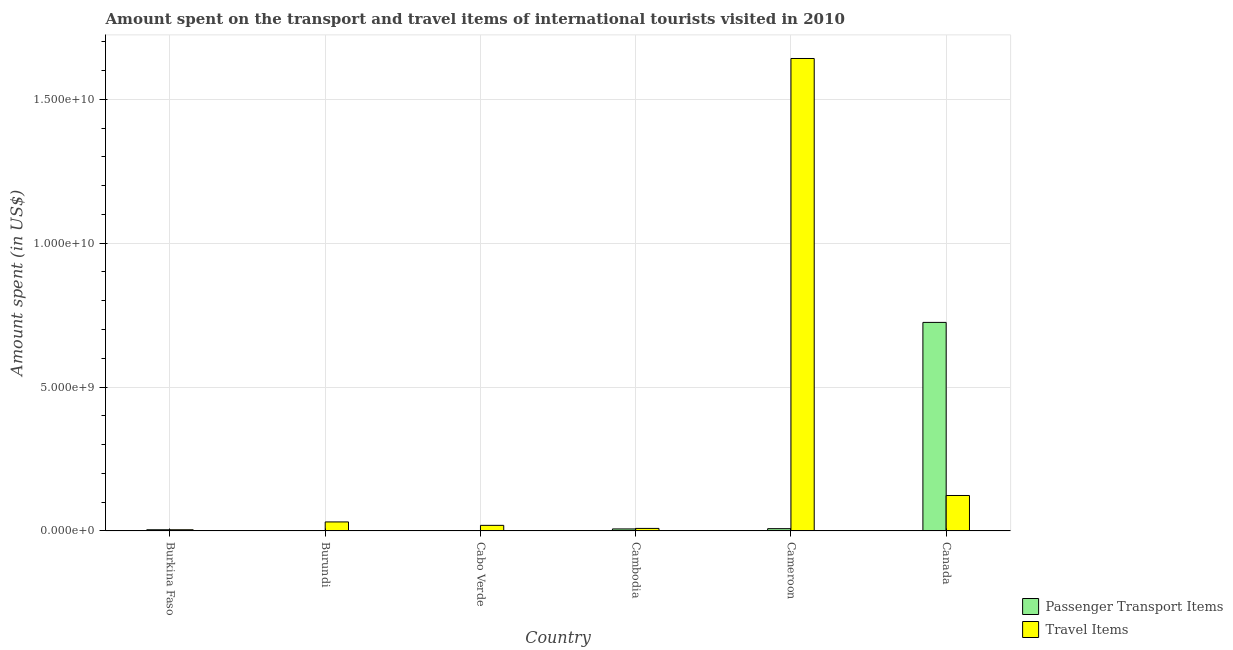How many groups of bars are there?
Your answer should be compact. 6. Are the number of bars on each tick of the X-axis equal?
Provide a short and direct response. Yes. How many bars are there on the 3rd tick from the left?
Provide a succinct answer. 2. How many bars are there on the 1st tick from the right?
Make the answer very short. 2. What is the label of the 3rd group of bars from the left?
Your answer should be compact. Cabo Verde. In how many cases, is the number of bars for a given country not equal to the number of legend labels?
Your response must be concise. 0. What is the amount spent in travel items in Burundi?
Offer a terse response. 3.13e+08. Across all countries, what is the maximum amount spent in travel items?
Your answer should be very brief. 1.64e+1. Across all countries, what is the minimum amount spent in travel items?
Give a very brief answer. 4.10e+07. In which country was the amount spent on passenger transport items maximum?
Offer a terse response. Canada. In which country was the amount spent in travel items minimum?
Provide a short and direct response. Burkina Faso. What is the total amount spent in travel items in the graph?
Offer a terse response. 1.83e+1. What is the difference between the amount spent on passenger transport items in Cambodia and that in Cameroon?
Make the answer very short. -9.00e+06. What is the difference between the amount spent on passenger transport items in Burundi and the amount spent in travel items in Cameroon?
Your answer should be compact. -1.64e+1. What is the average amount spent in travel items per country?
Keep it short and to the point. 3.05e+09. What is the difference between the amount spent in travel items and amount spent on passenger transport items in Burkina Faso?
Ensure brevity in your answer.  0. What is the ratio of the amount spent on passenger transport items in Burundi to that in Cabo Verde?
Provide a short and direct response. 1.67. Is the amount spent on passenger transport items in Burundi less than that in Cameroon?
Your response must be concise. Yes. Is the difference between the amount spent in travel items in Cameroon and Canada greater than the difference between the amount spent on passenger transport items in Cameroon and Canada?
Provide a succinct answer. Yes. What is the difference between the highest and the second highest amount spent in travel items?
Keep it short and to the point. 1.52e+1. What is the difference between the highest and the lowest amount spent on passenger transport items?
Make the answer very short. 7.24e+09. In how many countries, is the amount spent in travel items greater than the average amount spent in travel items taken over all countries?
Ensure brevity in your answer.  1. What does the 1st bar from the left in Canada represents?
Provide a short and direct response. Passenger Transport Items. What does the 1st bar from the right in Burundi represents?
Give a very brief answer. Travel Items. Are all the bars in the graph horizontal?
Your answer should be very brief. No. How many countries are there in the graph?
Offer a very short reply. 6. What is the difference between two consecutive major ticks on the Y-axis?
Keep it short and to the point. 5.00e+09. Does the graph contain any zero values?
Your answer should be compact. No. Does the graph contain grids?
Your answer should be compact. Yes. How many legend labels are there?
Give a very brief answer. 2. What is the title of the graph?
Keep it short and to the point. Amount spent on the transport and travel items of international tourists visited in 2010. Does "Technicians" appear as one of the legend labels in the graph?
Your answer should be very brief. No. What is the label or title of the Y-axis?
Keep it short and to the point. Amount spent (in US$). What is the Amount spent (in US$) in Passenger Transport Items in Burkina Faso?
Offer a terse response. 4.10e+07. What is the Amount spent (in US$) of Travel Items in Burkina Faso?
Ensure brevity in your answer.  4.10e+07. What is the Amount spent (in US$) in Passenger Transport Items in Burundi?
Ensure brevity in your answer.  1.50e+07. What is the Amount spent (in US$) in Travel Items in Burundi?
Offer a terse response. 3.13e+08. What is the Amount spent (in US$) of Passenger Transport Items in Cabo Verde?
Provide a short and direct response. 9.00e+06. What is the Amount spent (in US$) of Travel Items in Cabo Verde?
Ensure brevity in your answer.  1.94e+08. What is the Amount spent (in US$) in Passenger Transport Items in Cambodia?
Give a very brief answer. 7.00e+07. What is the Amount spent (in US$) in Travel Items in Cambodia?
Ensure brevity in your answer.  8.80e+07. What is the Amount spent (in US$) in Passenger Transport Items in Cameroon?
Ensure brevity in your answer.  7.90e+07. What is the Amount spent (in US$) in Travel Items in Cameroon?
Give a very brief answer. 1.64e+1. What is the Amount spent (in US$) in Passenger Transport Items in Canada?
Your answer should be very brief. 7.25e+09. What is the Amount spent (in US$) of Travel Items in Canada?
Ensure brevity in your answer.  1.23e+09. Across all countries, what is the maximum Amount spent (in US$) of Passenger Transport Items?
Offer a very short reply. 7.25e+09. Across all countries, what is the maximum Amount spent (in US$) in Travel Items?
Offer a very short reply. 1.64e+1. Across all countries, what is the minimum Amount spent (in US$) in Passenger Transport Items?
Your answer should be compact. 9.00e+06. Across all countries, what is the minimum Amount spent (in US$) of Travel Items?
Keep it short and to the point. 4.10e+07. What is the total Amount spent (in US$) of Passenger Transport Items in the graph?
Offer a very short reply. 7.46e+09. What is the total Amount spent (in US$) of Travel Items in the graph?
Ensure brevity in your answer.  1.83e+1. What is the difference between the Amount spent (in US$) in Passenger Transport Items in Burkina Faso and that in Burundi?
Your answer should be compact. 2.60e+07. What is the difference between the Amount spent (in US$) in Travel Items in Burkina Faso and that in Burundi?
Keep it short and to the point. -2.72e+08. What is the difference between the Amount spent (in US$) in Passenger Transport Items in Burkina Faso and that in Cabo Verde?
Offer a terse response. 3.20e+07. What is the difference between the Amount spent (in US$) of Travel Items in Burkina Faso and that in Cabo Verde?
Your answer should be very brief. -1.53e+08. What is the difference between the Amount spent (in US$) in Passenger Transport Items in Burkina Faso and that in Cambodia?
Keep it short and to the point. -2.90e+07. What is the difference between the Amount spent (in US$) of Travel Items in Burkina Faso and that in Cambodia?
Offer a terse response. -4.70e+07. What is the difference between the Amount spent (in US$) in Passenger Transport Items in Burkina Faso and that in Cameroon?
Your answer should be compact. -3.80e+07. What is the difference between the Amount spent (in US$) in Travel Items in Burkina Faso and that in Cameroon?
Give a very brief answer. -1.64e+1. What is the difference between the Amount spent (in US$) of Passenger Transport Items in Burkina Faso and that in Canada?
Your answer should be compact. -7.21e+09. What is the difference between the Amount spent (in US$) of Travel Items in Burkina Faso and that in Canada?
Provide a succinct answer. -1.19e+09. What is the difference between the Amount spent (in US$) in Passenger Transport Items in Burundi and that in Cabo Verde?
Provide a short and direct response. 6.00e+06. What is the difference between the Amount spent (in US$) in Travel Items in Burundi and that in Cabo Verde?
Offer a terse response. 1.19e+08. What is the difference between the Amount spent (in US$) of Passenger Transport Items in Burundi and that in Cambodia?
Provide a succinct answer. -5.50e+07. What is the difference between the Amount spent (in US$) of Travel Items in Burundi and that in Cambodia?
Make the answer very short. 2.25e+08. What is the difference between the Amount spent (in US$) of Passenger Transport Items in Burundi and that in Cameroon?
Provide a succinct answer. -6.40e+07. What is the difference between the Amount spent (in US$) in Travel Items in Burundi and that in Cameroon?
Your answer should be very brief. -1.61e+1. What is the difference between the Amount spent (in US$) in Passenger Transport Items in Burundi and that in Canada?
Your answer should be very brief. -7.23e+09. What is the difference between the Amount spent (in US$) of Travel Items in Burundi and that in Canada?
Offer a very short reply. -9.19e+08. What is the difference between the Amount spent (in US$) of Passenger Transport Items in Cabo Verde and that in Cambodia?
Your answer should be compact. -6.10e+07. What is the difference between the Amount spent (in US$) of Travel Items in Cabo Verde and that in Cambodia?
Your answer should be very brief. 1.06e+08. What is the difference between the Amount spent (in US$) in Passenger Transport Items in Cabo Verde and that in Cameroon?
Make the answer very short. -7.00e+07. What is the difference between the Amount spent (in US$) of Travel Items in Cabo Verde and that in Cameroon?
Provide a succinct answer. -1.62e+1. What is the difference between the Amount spent (in US$) in Passenger Transport Items in Cabo Verde and that in Canada?
Your answer should be compact. -7.24e+09. What is the difference between the Amount spent (in US$) in Travel Items in Cabo Verde and that in Canada?
Offer a terse response. -1.04e+09. What is the difference between the Amount spent (in US$) of Passenger Transport Items in Cambodia and that in Cameroon?
Keep it short and to the point. -9.00e+06. What is the difference between the Amount spent (in US$) in Travel Items in Cambodia and that in Cameroon?
Your answer should be compact. -1.63e+1. What is the difference between the Amount spent (in US$) of Passenger Transport Items in Cambodia and that in Canada?
Your answer should be very brief. -7.18e+09. What is the difference between the Amount spent (in US$) in Travel Items in Cambodia and that in Canada?
Keep it short and to the point. -1.14e+09. What is the difference between the Amount spent (in US$) in Passenger Transport Items in Cameroon and that in Canada?
Offer a very short reply. -7.17e+09. What is the difference between the Amount spent (in US$) in Travel Items in Cameroon and that in Canada?
Give a very brief answer. 1.52e+1. What is the difference between the Amount spent (in US$) in Passenger Transport Items in Burkina Faso and the Amount spent (in US$) in Travel Items in Burundi?
Give a very brief answer. -2.72e+08. What is the difference between the Amount spent (in US$) in Passenger Transport Items in Burkina Faso and the Amount spent (in US$) in Travel Items in Cabo Verde?
Your response must be concise. -1.53e+08. What is the difference between the Amount spent (in US$) of Passenger Transport Items in Burkina Faso and the Amount spent (in US$) of Travel Items in Cambodia?
Ensure brevity in your answer.  -4.70e+07. What is the difference between the Amount spent (in US$) in Passenger Transport Items in Burkina Faso and the Amount spent (in US$) in Travel Items in Cameroon?
Offer a very short reply. -1.64e+1. What is the difference between the Amount spent (in US$) of Passenger Transport Items in Burkina Faso and the Amount spent (in US$) of Travel Items in Canada?
Offer a terse response. -1.19e+09. What is the difference between the Amount spent (in US$) in Passenger Transport Items in Burundi and the Amount spent (in US$) in Travel Items in Cabo Verde?
Give a very brief answer. -1.79e+08. What is the difference between the Amount spent (in US$) of Passenger Transport Items in Burundi and the Amount spent (in US$) of Travel Items in Cambodia?
Give a very brief answer. -7.30e+07. What is the difference between the Amount spent (in US$) of Passenger Transport Items in Burundi and the Amount spent (in US$) of Travel Items in Cameroon?
Ensure brevity in your answer.  -1.64e+1. What is the difference between the Amount spent (in US$) of Passenger Transport Items in Burundi and the Amount spent (in US$) of Travel Items in Canada?
Your answer should be very brief. -1.22e+09. What is the difference between the Amount spent (in US$) in Passenger Transport Items in Cabo Verde and the Amount spent (in US$) in Travel Items in Cambodia?
Ensure brevity in your answer.  -7.90e+07. What is the difference between the Amount spent (in US$) of Passenger Transport Items in Cabo Verde and the Amount spent (in US$) of Travel Items in Cameroon?
Your answer should be very brief. -1.64e+1. What is the difference between the Amount spent (in US$) of Passenger Transport Items in Cabo Verde and the Amount spent (in US$) of Travel Items in Canada?
Provide a succinct answer. -1.22e+09. What is the difference between the Amount spent (in US$) in Passenger Transport Items in Cambodia and the Amount spent (in US$) in Travel Items in Cameroon?
Provide a succinct answer. -1.64e+1. What is the difference between the Amount spent (in US$) in Passenger Transport Items in Cambodia and the Amount spent (in US$) in Travel Items in Canada?
Your answer should be compact. -1.16e+09. What is the difference between the Amount spent (in US$) in Passenger Transport Items in Cameroon and the Amount spent (in US$) in Travel Items in Canada?
Provide a short and direct response. -1.15e+09. What is the average Amount spent (in US$) of Passenger Transport Items per country?
Keep it short and to the point. 1.24e+09. What is the average Amount spent (in US$) in Travel Items per country?
Your answer should be compact. 3.05e+09. What is the difference between the Amount spent (in US$) of Passenger Transport Items and Amount spent (in US$) of Travel Items in Burkina Faso?
Keep it short and to the point. 0. What is the difference between the Amount spent (in US$) in Passenger Transport Items and Amount spent (in US$) in Travel Items in Burundi?
Provide a succinct answer. -2.98e+08. What is the difference between the Amount spent (in US$) of Passenger Transport Items and Amount spent (in US$) of Travel Items in Cabo Verde?
Your answer should be compact. -1.85e+08. What is the difference between the Amount spent (in US$) of Passenger Transport Items and Amount spent (in US$) of Travel Items in Cambodia?
Your answer should be compact. -1.80e+07. What is the difference between the Amount spent (in US$) in Passenger Transport Items and Amount spent (in US$) in Travel Items in Cameroon?
Keep it short and to the point. -1.63e+1. What is the difference between the Amount spent (in US$) in Passenger Transport Items and Amount spent (in US$) in Travel Items in Canada?
Ensure brevity in your answer.  6.02e+09. What is the ratio of the Amount spent (in US$) of Passenger Transport Items in Burkina Faso to that in Burundi?
Make the answer very short. 2.73. What is the ratio of the Amount spent (in US$) of Travel Items in Burkina Faso to that in Burundi?
Keep it short and to the point. 0.13. What is the ratio of the Amount spent (in US$) in Passenger Transport Items in Burkina Faso to that in Cabo Verde?
Keep it short and to the point. 4.56. What is the ratio of the Amount spent (in US$) in Travel Items in Burkina Faso to that in Cabo Verde?
Your answer should be very brief. 0.21. What is the ratio of the Amount spent (in US$) in Passenger Transport Items in Burkina Faso to that in Cambodia?
Offer a very short reply. 0.59. What is the ratio of the Amount spent (in US$) of Travel Items in Burkina Faso to that in Cambodia?
Provide a succinct answer. 0.47. What is the ratio of the Amount spent (in US$) in Passenger Transport Items in Burkina Faso to that in Cameroon?
Make the answer very short. 0.52. What is the ratio of the Amount spent (in US$) of Travel Items in Burkina Faso to that in Cameroon?
Provide a succinct answer. 0. What is the ratio of the Amount spent (in US$) of Passenger Transport Items in Burkina Faso to that in Canada?
Your response must be concise. 0.01. What is the ratio of the Amount spent (in US$) of Passenger Transport Items in Burundi to that in Cabo Verde?
Give a very brief answer. 1.67. What is the ratio of the Amount spent (in US$) in Travel Items in Burundi to that in Cabo Verde?
Offer a very short reply. 1.61. What is the ratio of the Amount spent (in US$) in Passenger Transport Items in Burundi to that in Cambodia?
Provide a short and direct response. 0.21. What is the ratio of the Amount spent (in US$) of Travel Items in Burundi to that in Cambodia?
Provide a succinct answer. 3.56. What is the ratio of the Amount spent (in US$) in Passenger Transport Items in Burundi to that in Cameroon?
Make the answer very short. 0.19. What is the ratio of the Amount spent (in US$) of Travel Items in Burundi to that in Cameroon?
Give a very brief answer. 0.02. What is the ratio of the Amount spent (in US$) in Passenger Transport Items in Burundi to that in Canada?
Offer a very short reply. 0. What is the ratio of the Amount spent (in US$) of Travel Items in Burundi to that in Canada?
Provide a succinct answer. 0.25. What is the ratio of the Amount spent (in US$) of Passenger Transport Items in Cabo Verde to that in Cambodia?
Give a very brief answer. 0.13. What is the ratio of the Amount spent (in US$) of Travel Items in Cabo Verde to that in Cambodia?
Your answer should be very brief. 2.2. What is the ratio of the Amount spent (in US$) of Passenger Transport Items in Cabo Verde to that in Cameroon?
Offer a terse response. 0.11. What is the ratio of the Amount spent (in US$) in Travel Items in Cabo Verde to that in Cameroon?
Ensure brevity in your answer.  0.01. What is the ratio of the Amount spent (in US$) in Passenger Transport Items in Cabo Verde to that in Canada?
Provide a short and direct response. 0. What is the ratio of the Amount spent (in US$) in Travel Items in Cabo Verde to that in Canada?
Keep it short and to the point. 0.16. What is the ratio of the Amount spent (in US$) in Passenger Transport Items in Cambodia to that in Cameroon?
Provide a short and direct response. 0.89. What is the ratio of the Amount spent (in US$) of Travel Items in Cambodia to that in Cameroon?
Make the answer very short. 0.01. What is the ratio of the Amount spent (in US$) in Passenger Transport Items in Cambodia to that in Canada?
Provide a succinct answer. 0.01. What is the ratio of the Amount spent (in US$) in Travel Items in Cambodia to that in Canada?
Provide a succinct answer. 0.07. What is the ratio of the Amount spent (in US$) of Passenger Transport Items in Cameroon to that in Canada?
Provide a short and direct response. 0.01. What is the ratio of the Amount spent (in US$) in Travel Items in Cameroon to that in Canada?
Provide a short and direct response. 13.33. What is the difference between the highest and the second highest Amount spent (in US$) of Passenger Transport Items?
Make the answer very short. 7.17e+09. What is the difference between the highest and the second highest Amount spent (in US$) in Travel Items?
Make the answer very short. 1.52e+1. What is the difference between the highest and the lowest Amount spent (in US$) in Passenger Transport Items?
Your answer should be compact. 7.24e+09. What is the difference between the highest and the lowest Amount spent (in US$) in Travel Items?
Your answer should be very brief. 1.64e+1. 